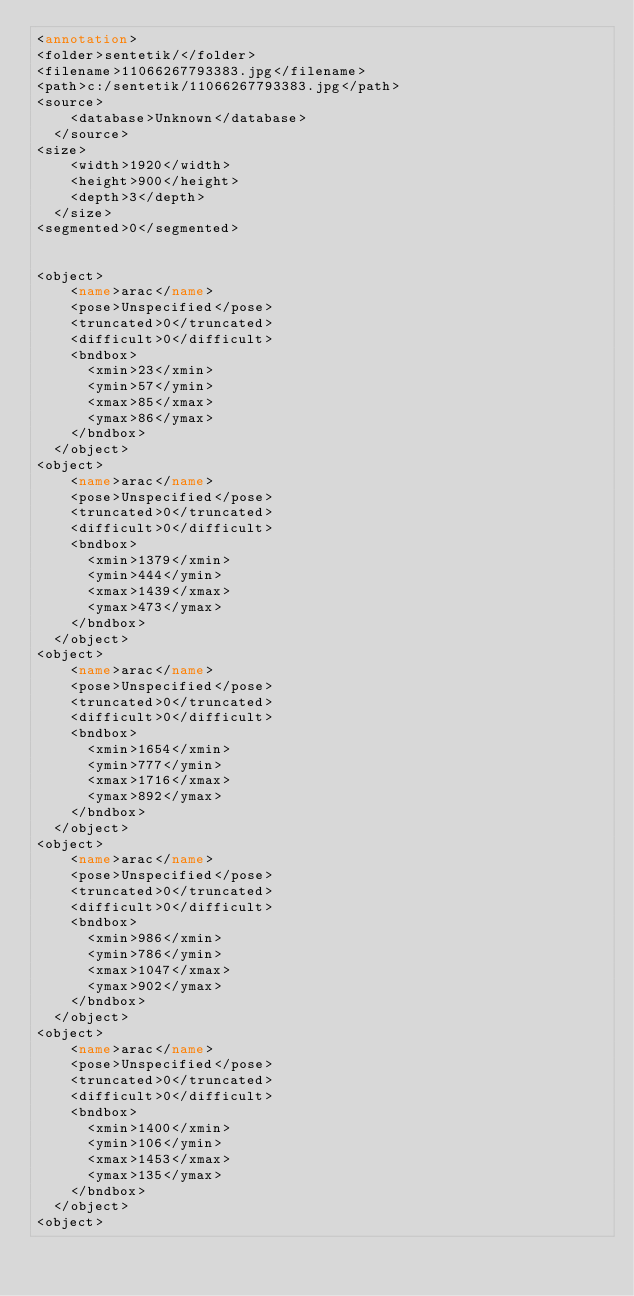Convert code to text. <code><loc_0><loc_0><loc_500><loc_500><_XML_><annotation>
<folder>sentetik/</folder>
<filename>11066267793383.jpg</filename>
<path>c:/sentetik/11066267793383.jpg</path>
<source>
		<database>Unknown</database>
	</source>
<size>
		<width>1920</width>
		<height>900</height>
		<depth>3</depth>
	</size>
<segmented>0</segmented>


<object>
		<name>arac</name>
		<pose>Unspecified</pose>
		<truncated>0</truncated>
		<difficult>0</difficult>
		<bndbox>
			<xmin>23</xmin>
			<ymin>57</ymin>
			<xmax>85</xmax>
			<ymax>86</ymax>
		</bndbox>
	</object>
<object>
		<name>arac</name>
		<pose>Unspecified</pose>
		<truncated>0</truncated>
		<difficult>0</difficult>
		<bndbox>
			<xmin>1379</xmin>
			<ymin>444</ymin>
			<xmax>1439</xmax>
			<ymax>473</ymax>
		</bndbox>
	</object>
<object>
		<name>arac</name>
		<pose>Unspecified</pose>
		<truncated>0</truncated>
		<difficult>0</difficult>
		<bndbox>
			<xmin>1654</xmin>
			<ymin>777</ymin>
			<xmax>1716</xmax>
			<ymax>892</ymax>
		</bndbox>
	</object>
<object>
		<name>arac</name>
		<pose>Unspecified</pose>
		<truncated>0</truncated>
		<difficult>0</difficult>
		<bndbox>
			<xmin>986</xmin>
			<ymin>786</ymin>
			<xmax>1047</xmax>
			<ymax>902</ymax>
		</bndbox>
	</object>
<object>
		<name>arac</name>
		<pose>Unspecified</pose>
		<truncated>0</truncated>
		<difficult>0</difficult>
		<bndbox>
			<xmin>1400</xmin>
			<ymin>106</ymin>
			<xmax>1453</xmax>
			<ymax>135</ymax>
		</bndbox>
	</object>
<object></code> 